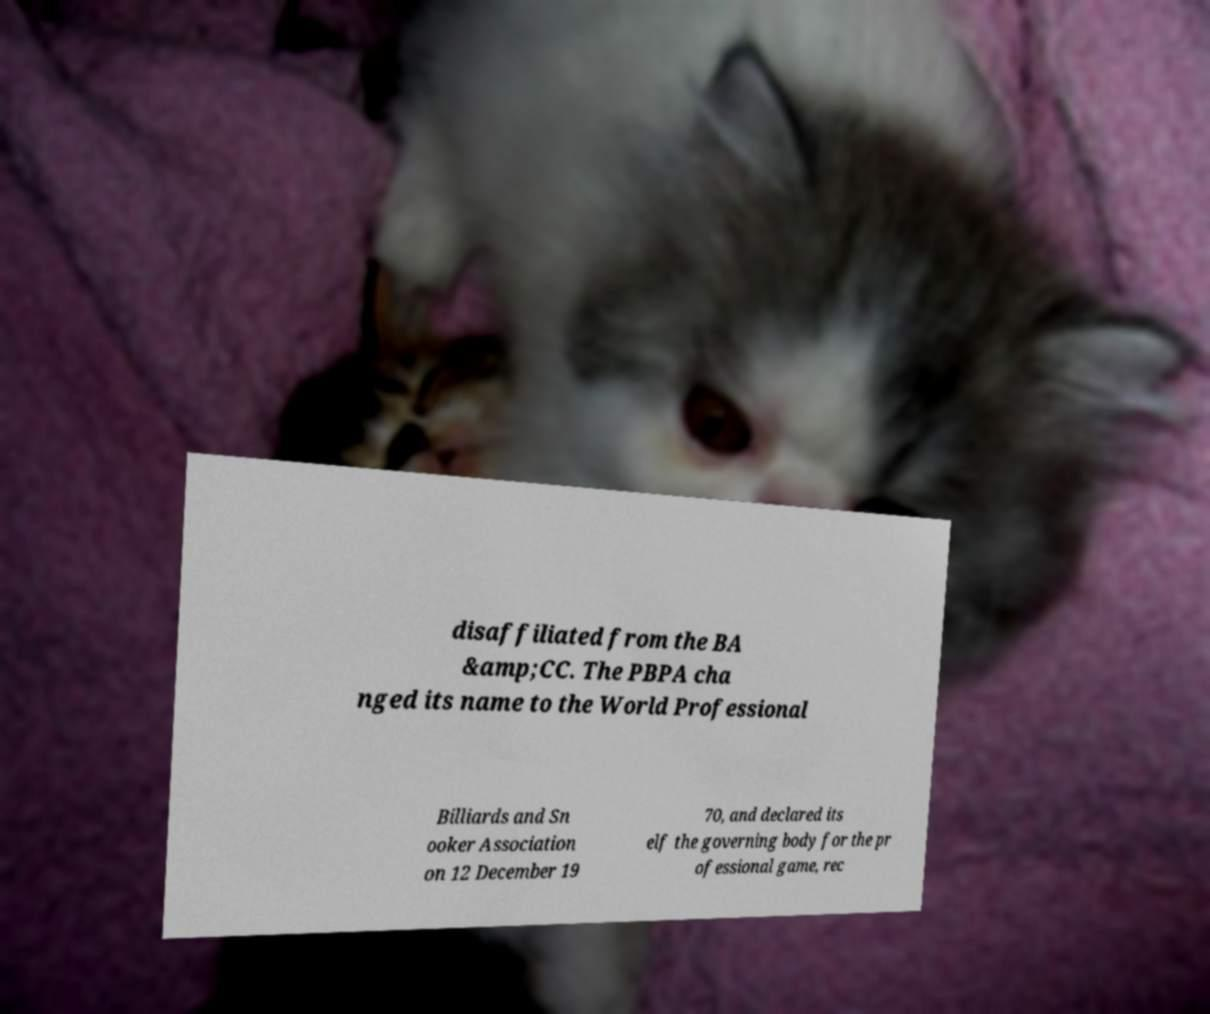For documentation purposes, I need the text within this image transcribed. Could you provide that? disaffiliated from the BA &amp;CC. The PBPA cha nged its name to the World Professional Billiards and Sn ooker Association on 12 December 19 70, and declared its elf the governing body for the pr ofessional game, rec 